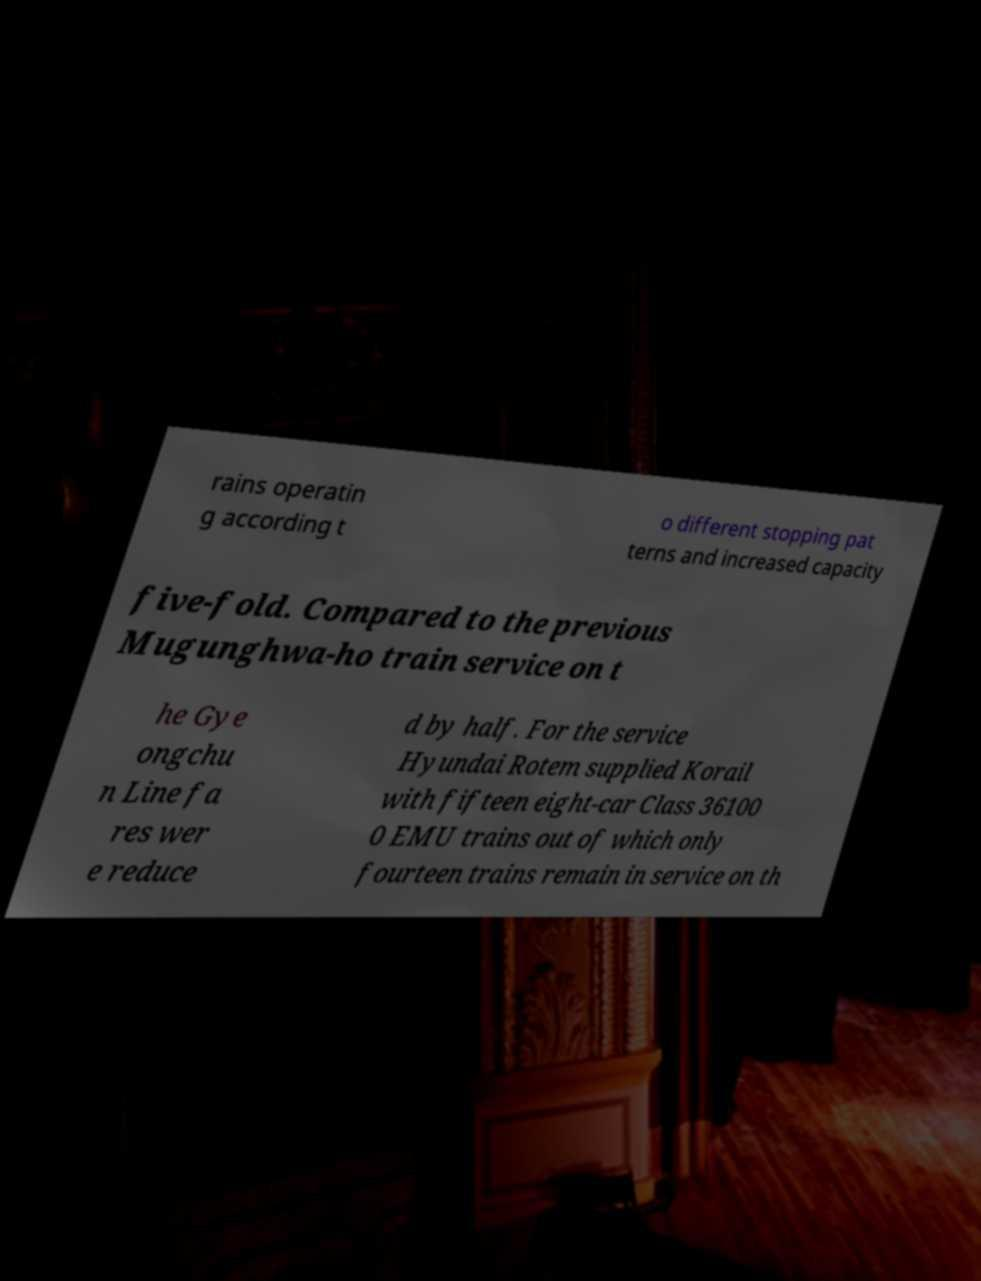Please read and relay the text visible in this image. What does it say? rains operatin g according t o different stopping pat terns and increased capacity five-fold. Compared to the previous Mugunghwa-ho train service on t he Gye ongchu n Line fa res wer e reduce d by half. For the service Hyundai Rotem supplied Korail with fifteen eight-car Class 36100 0 EMU trains out of which only fourteen trains remain in service on th 